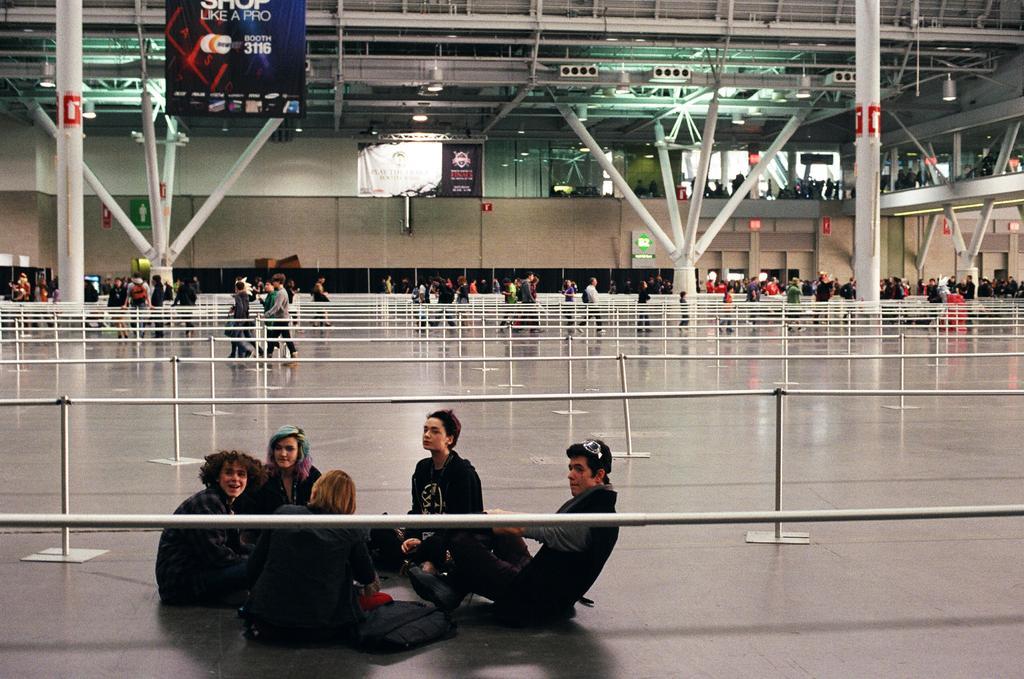How would you summarize this image in a sentence or two? At the bottom of the image we can see people are sitting on the floor. In the background, we can see railings, people, pillars, banners and wall. At the top of the image, we can see the roof. 